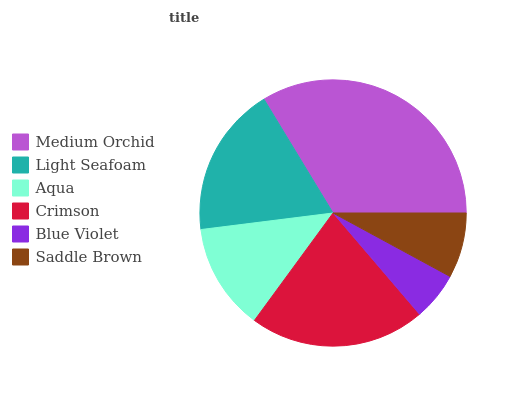Is Blue Violet the minimum?
Answer yes or no. Yes. Is Medium Orchid the maximum?
Answer yes or no. Yes. Is Light Seafoam the minimum?
Answer yes or no. No. Is Light Seafoam the maximum?
Answer yes or no. No. Is Medium Orchid greater than Light Seafoam?
Answer yes or no. Yes. Is Light Seafoam less than Medium Orchid?
Answer yes or no. Yes. Is Light Seafoam greater than Medium Orchid?
Answer yes or no. No. Is Medium Orchid less than Light Seafoam?
Answer yes or no. No. Is Light Seafoam the high median?
Answer yes or no. Yes. Is Aqua the low median?
Answer yes or no. Yes. Is Aqua the high median?
Answer yes or no. No. Is Light Seafoam the low median?
Answer yes or no. No. 